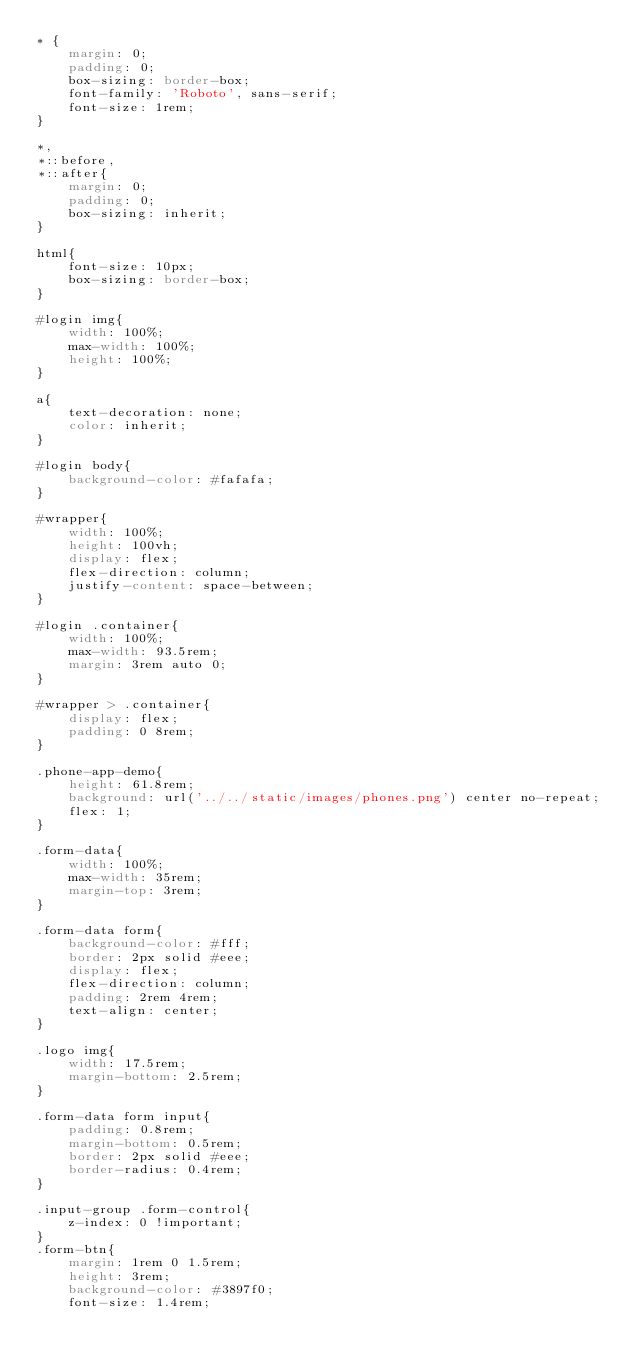<code> <loc_0><loc_0><loc_500><loc_500><_CSS_>* {
    margin: 0;
    padding: 0;
    box-sizing: border-box;
    font-family: 'Roboto', sans-serif;
    font-size: 1rem;
}

*,
*::before,
*::after{
    margin: 0;
    padding: 0;
    box-sizing: inherit;
}

html{
    font-size: 10px;
    box-sizing: border-box;
}

#login img{
    width: 100%;
    max-width: 100%;
    height: 100%;
}

a{
    text-decoration: none;
    color: inherit;
}

#login body{
    background-color: #fafafa;
}

#wrapper{
    width: 100%;
    height: 100vh;
    display: flex;
    flex-direction: column;
    justify-content: space-between;
}

#login .container{
    width: 100%;
    max-width: 93.5rem;
    margin: 3rem auto 0;
}

#wrapper > .container{
    display: flex;
    padding: 0 8rem;
}

.phone-app-demo{
    height: 61.8rem;
    background: url('../../static/images/phones.png') center no-repeat;
    flex: 1;
}

.form-data{
    width: 100%;
    max-width: 35rem;
    margin-top: 3rem;
}

.form-data form{
    background-color: #fff;
    border: 2px solid #eee;
    display: flex;
    flex-direction: column;
    padding: 2rem 4rem;
    text-align: center;
}

.logo img{
    width: 17.5rem;
    margin-bottom: 2.5rem;
}

.form-data form input{
    padding: 0.8rem;
    margin-bottom: 0.5rem;
    border: 2px solid #eee;
    border-radius: 0.4rem;
}

.input-group .form-control{
    z-index: 0 !important;
}
.form-btn{
    margin: 1rem 0 1.5rem;
    height: 3rem;
    background-color: #3897f0;
    font-size: 1.4rem;</code> 